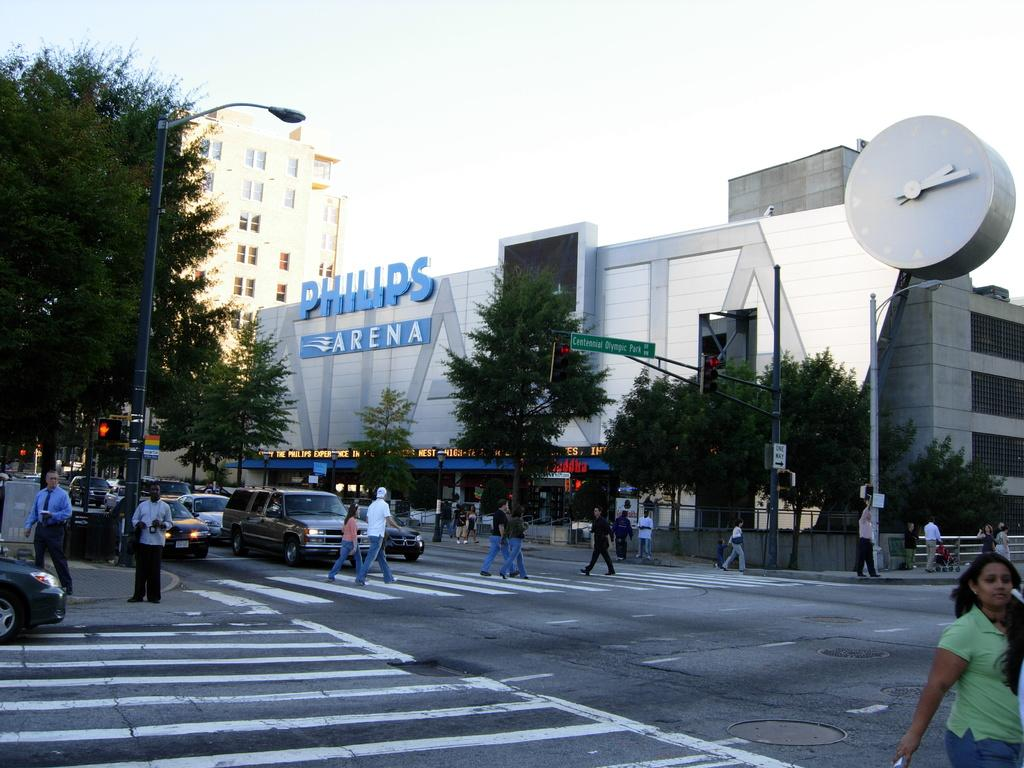What is the main feature of the image? There is a road in the image. What is happening on the road? There are people and vehicles on the road. What can be seen in the background of the image? There are trees and buildings in the image. How many street lights are visible in the image? There are two street lights in the image. How does the hose help the people on the road in the image? There is no hose present in the image, so it cannot help the people on the road. 